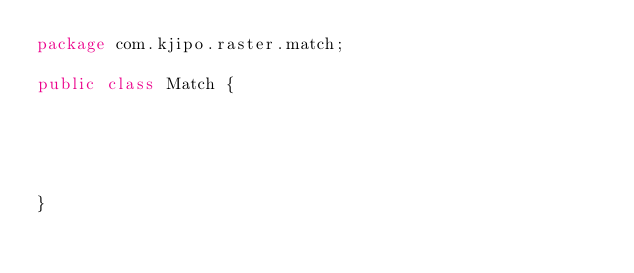Convert code to text. <code><loc_0><loc_0><loc_500><loc_500><_Java_>package com.kjipo.raster.match;

public class Match {





}
</code> 